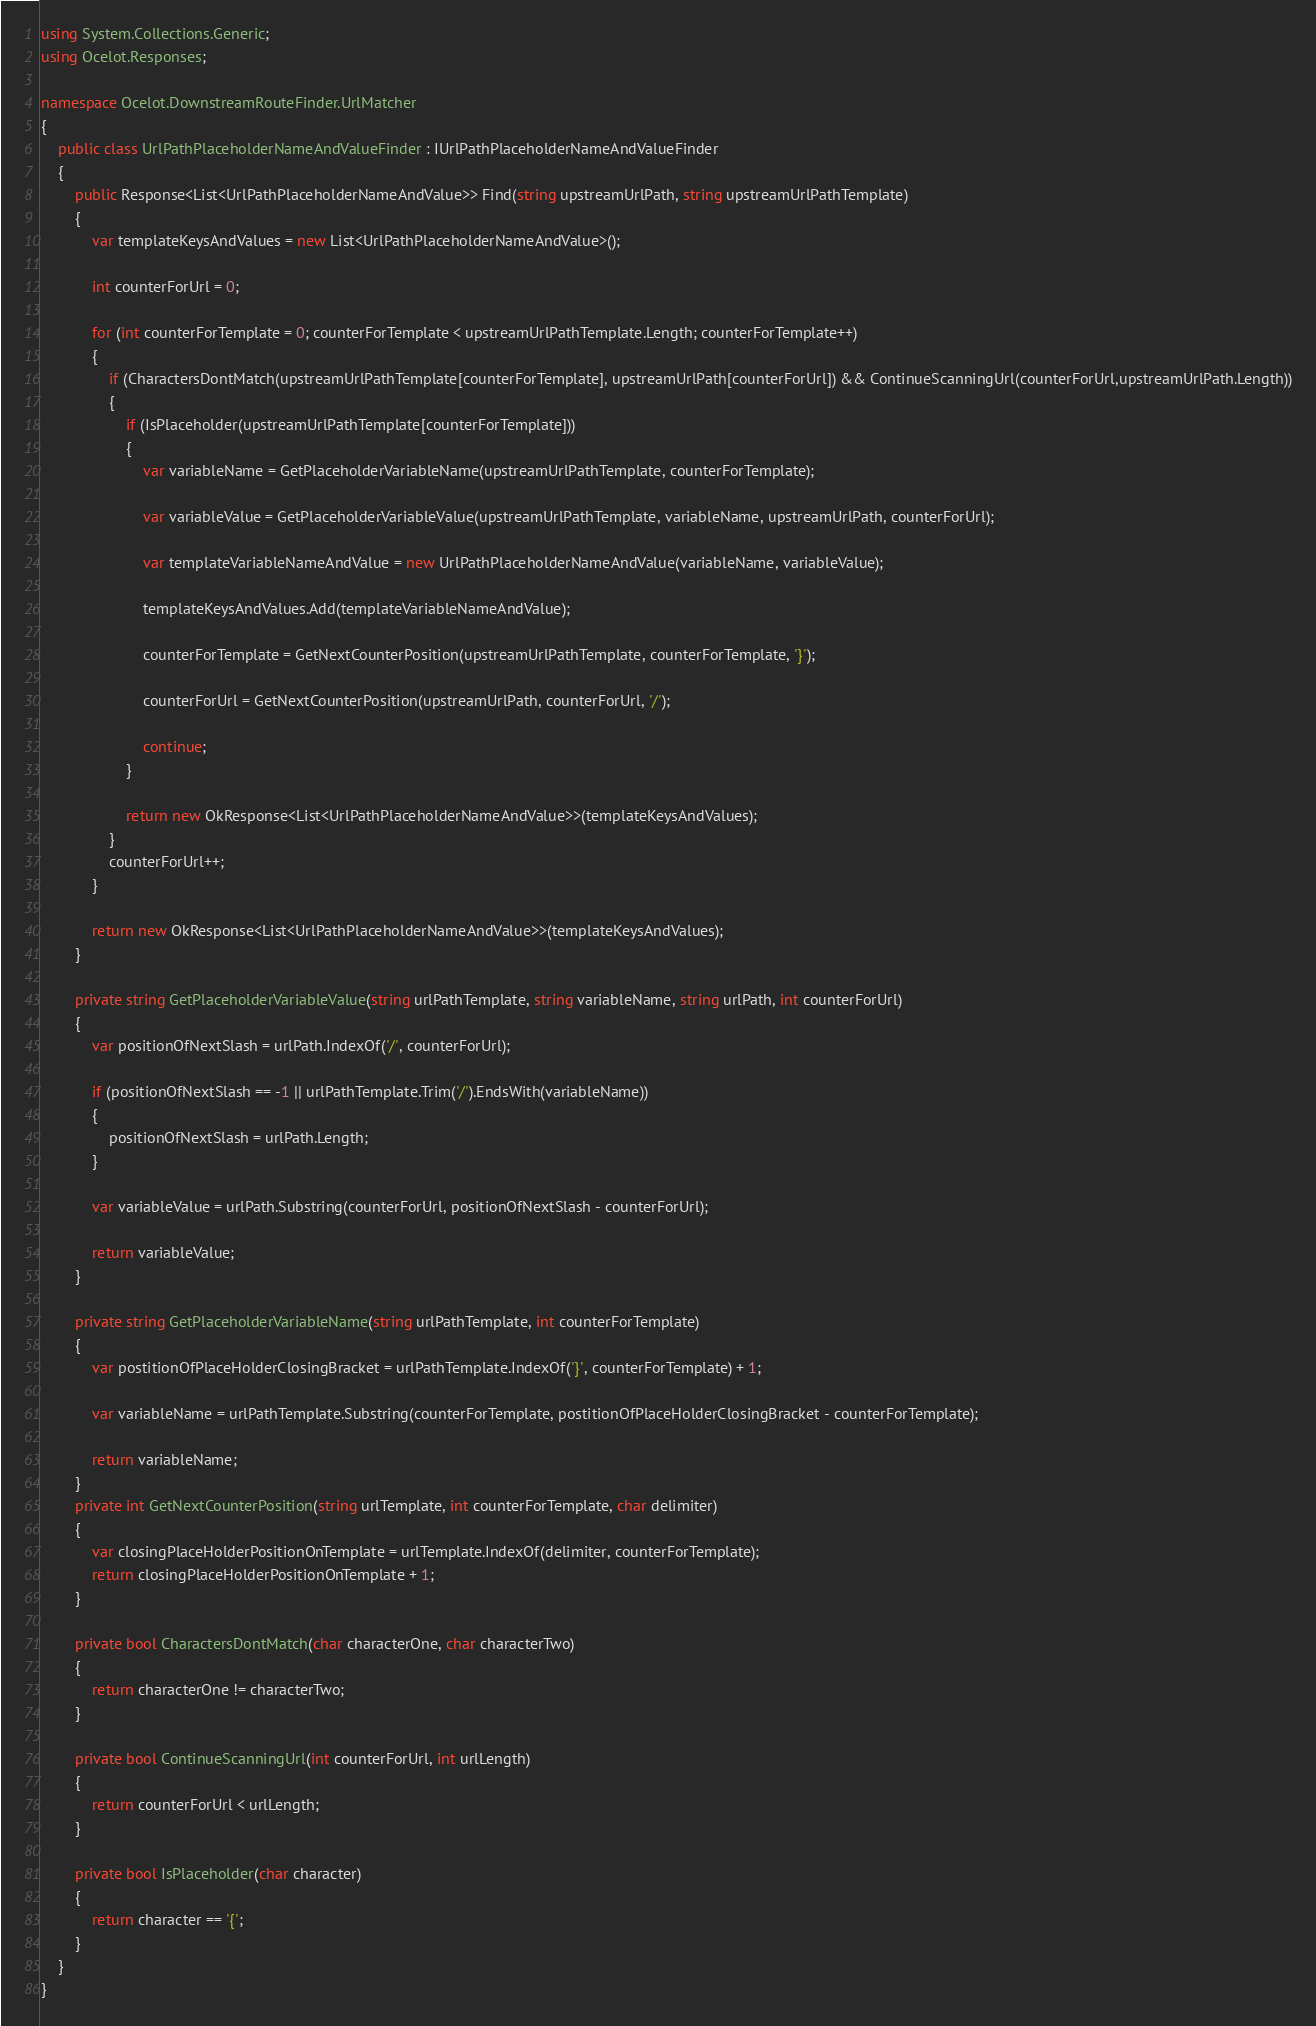Convert code to text. <code><loc_0><loc_0><loc_500><loc_500><_C#_>using System.Collections.Generic;
using Ocelot.Responses;

namespace Ocelot.DownstreamRouteFinder.UrlMatcher
{
    public class UrlPathPlaceholderNameAndValueFinder : IUrlPathPlaceholderNameAndValueFinder
    {
        public Response<List<UrlPathPlaceholderNameAndValue>> Find(string upstreamUrlPath, string upstreamUrlPathTemplate)
        {
            var templateKeysAndValues = new List<UrlPathPlaceholderNameAndValue>();

            int counterForUrl = 0;
         
            for (int counterForTemplate = 0; counterForTemplate < upstreamUrlPathTemplate.Length; counterForTemplate++)
            {
                if (CharactersDontMatch(upstreamUrlPathTemplate[counterForTemplate], upstreamUrlPath[counterForUrl]) && ContinueScanningUrl(counterForUrl,upstreamUrlPath.Length))
                {
                    if (IsPlaceholder(upstreamUrlPathTemplate[counterForTemplate]))
                    {
                        var variableName = GetPlaceholderVariableName(upstreamUrlPathTemplate, counterForTemplate);

                        var variableValue = GetPlaceholderVariableValue(upstreamUrlPathTemplate, variableName, upstreamUrlPath, counterForUrl);

                        var templateVariableNameAndValue = new UrlPathPlaceholderNameAndValue(variableName, variableValue);

                        templateKeysAndValues.Add(templateVariableNameAndValue);

                        counterForTemplate = GetNextCounterPosition(upstreamUrlPathTemplate, counterForTemplate, '}');

                        counterForUrl = GetNextCounterPosition(upstreamUrlPath, counterForUrl, '/');

                        continue;
                    }

                    return new OkResponse<List<UrlPathPlaceholderNameAndValue>>(templateKeysAndValues);
                }
                counterForUrl++;
            }

            return new OkResponse<List<UrlPathPlaceholderNameAndValue>>(templateKeysAndValues);
        }

        private string GetPlaceholderVariableValue(string urlPathTemplate, string variableName, string urlPath, int counterForUrl)
        {
            var positionOfNextSlash = urlPath.IndexOf('/', counterForUrl);

            if (positionOfNextSlash == -1 || urlPathTemplate.Trim('/').EndsWith(variableName))
            {
                positionOfNextSlash = urlPath.Length;
            }

            var variableValue = urlPath.Substring(counterForUrl, positionOfNextSlash - counterForUrl);

            return variableValue;
        }

        private string GetPlaceholderVariableName(string urlPathTemplate, int counterForTemplate)
        {
            var postitionOfPlaceHolderClosingBracket = urlPathTemplate.IndexOf('}', counterForTemplate) + 1;

            var variableName = urlPathTemplate.Substring(counterForTemplate, postitionOfPlaceHolderClosingBracket - counterForTemplate);

            return variableName;
        }
        private int GetNextCounterPosition(string urlTemplate, int counterForTemplate, char delimiter)
        {                        
            var closingPlaceHolderPositionOnTemplate = urlTemplate.IndexOf(delimiter, counterForTemplate);
            return closingPlaceHolderPositionOnTemplate + 1; 
        }

        private bool CharactersDontMatch(char characterOne, char characterTwo)
        {
            return characterOne != characterTwo;
        }

        private bool ContinueScanningUrl(int counterForUrl, int urlLength)
        {
            return counterForUrl < urlLength;
        }

        private bool IsPlaceholder(char character)
        {
            return character == '{';
        }
    }
}</code> 